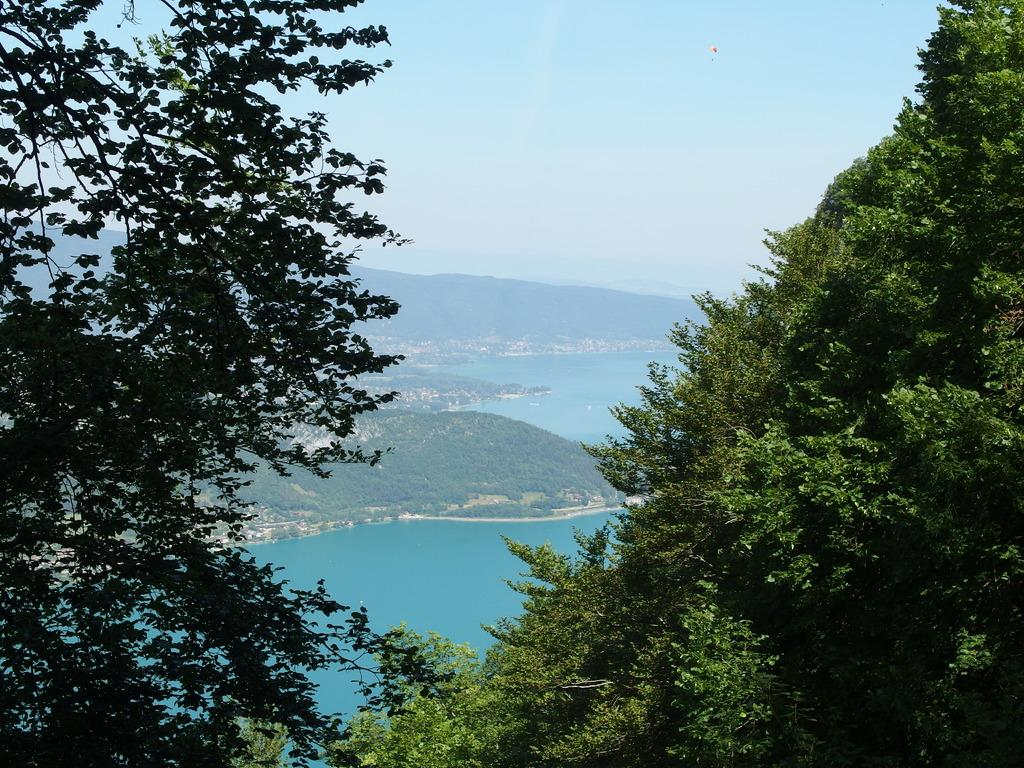What can be seen in the foreground of the picture? There are trees in the foreground of the picture. What is located in the center of the picture? There are hills covered with trees and a water body in the center of the picture. What is visible at the top of the picture? The sky is visible at the top of the picture. Where is the plough located in the image? There is no plough present in the image. What type of school can be seen in the image? There is no school present in the image. 